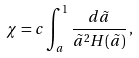Convert formula to latex. <formula><loc_0><loc_0><loc_500><loc_500>\chi = c \int _ { a } ^ { 1 } \frac { d \tilde { a } } { \tilde { a } ^ { 2 } H ( \tilde { a } ) } \, ,</formula> 